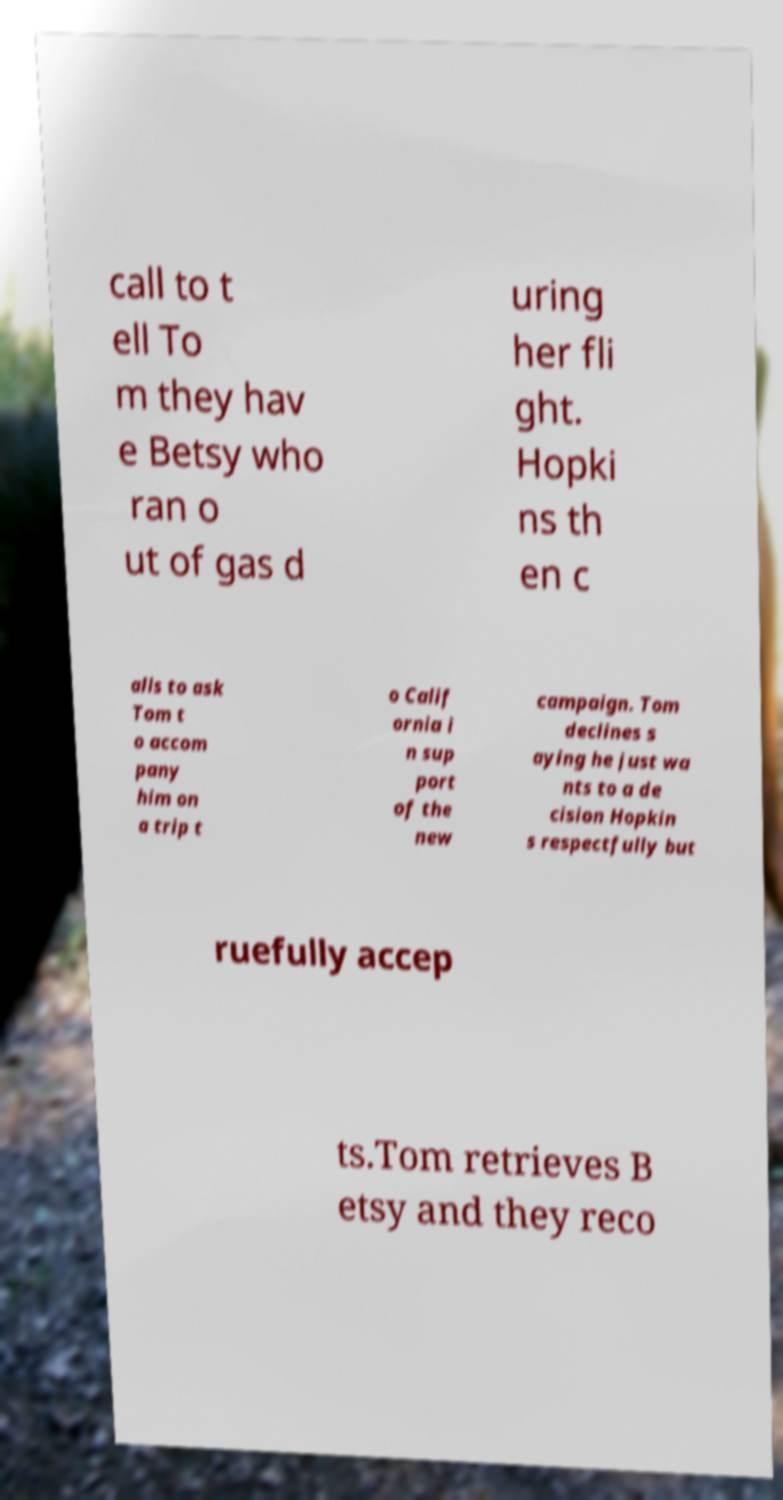There's text embedded in this image that I need extracted. Can you transcribe it verbatim? call to t ell To m they hav e Betsy who ran o ut of gas d uring her fli ght. Hopki ns th en c alls to ask Tom t o accom pany him on a trip t o Calif ornia i n sup port of the new campaign. Tom declines s aying he just wa nts to a de cision Hopkin s respectfully but ruefully accep ts.Tom retrieves B etsy and they reco 